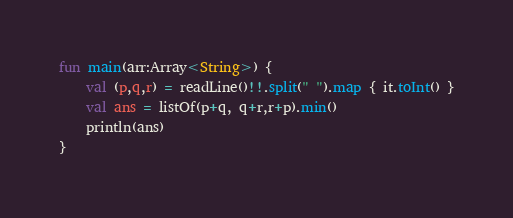<code> <loc_0><loc_0><loc_500><loc_500><_Kotlin_>fun main(arr:Array<String>) {
    val (p,q,r) = readLine()!!.split(" ").map { it.toInt() }
    val ans = listOf(p+q, q+r,r+p).min()
    println(ans)
}
</code> 